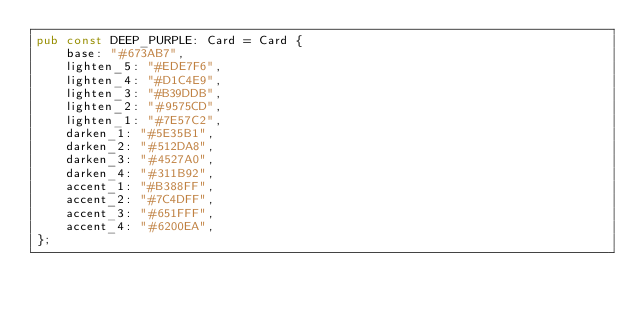Convert code to text. <code><loc_0><loc_0><loc_500><loc_500><_Rust_>pub const DEEP_PURPLE: Card = Card {
    base: "#673AB7",
    lighten_5: "#EDE7F6",
    lighten_4: "#D1C4E9",
    lighten_3: "#B39DDB",
    lighten_2: "#9575CD",
    lighten_1: "#7E57C2",
    darken_1: "#5E35B1",
    darken_2: "#512DA8",
    darken_3: "#4527A0",
    darken_4: "#311B92",
    accent_1: "#B388FF",
    accent_2: "#7C4DFF",
    accent_3: "#651FFF",
    accent_4: "#6200EA",
};
</code> 